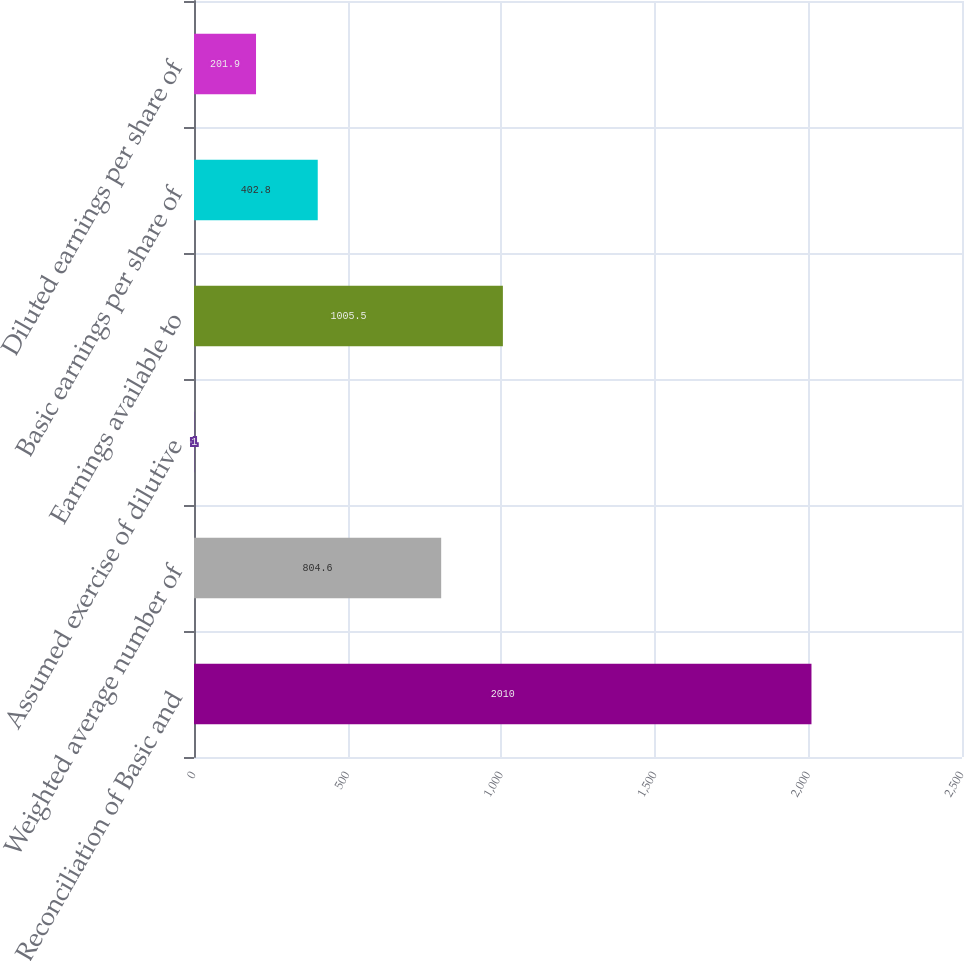<chart> <loc_0><loc_0><loc_500><loc_500><bar_chart><fcel>Reconciliation of Basic and<fcel>Weighted average number of<fcel>Assumed exercise of dilutive<fcel>Earnings available to<fcel>Basic earnings per share of<fcel>Diluted earnings per share of<nl><fcel>2010<fcel>804.6<fcel>1<fcel>1005.5<fcel>402.8<fcel>201.9<nl></chart> 